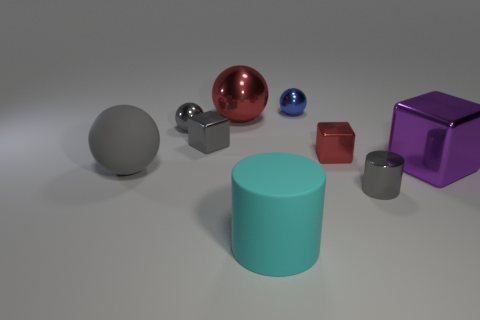Subtract 1 spheres. How many spheres are left? 3 Add 1 gray cubes. How many objects exist? 10 Subtract all balls. How many objects are left? 5 Subtract all tiny gray shiny spheres. Subtract all big matte spheres. How many objects are left? 7 Add 9 red blocks. How many red blocks are left? 10 Add 5 small cyan spheres. How many small cyan spheres exist? 5 Subtract 0 green blocks. How many objects are left? 9 